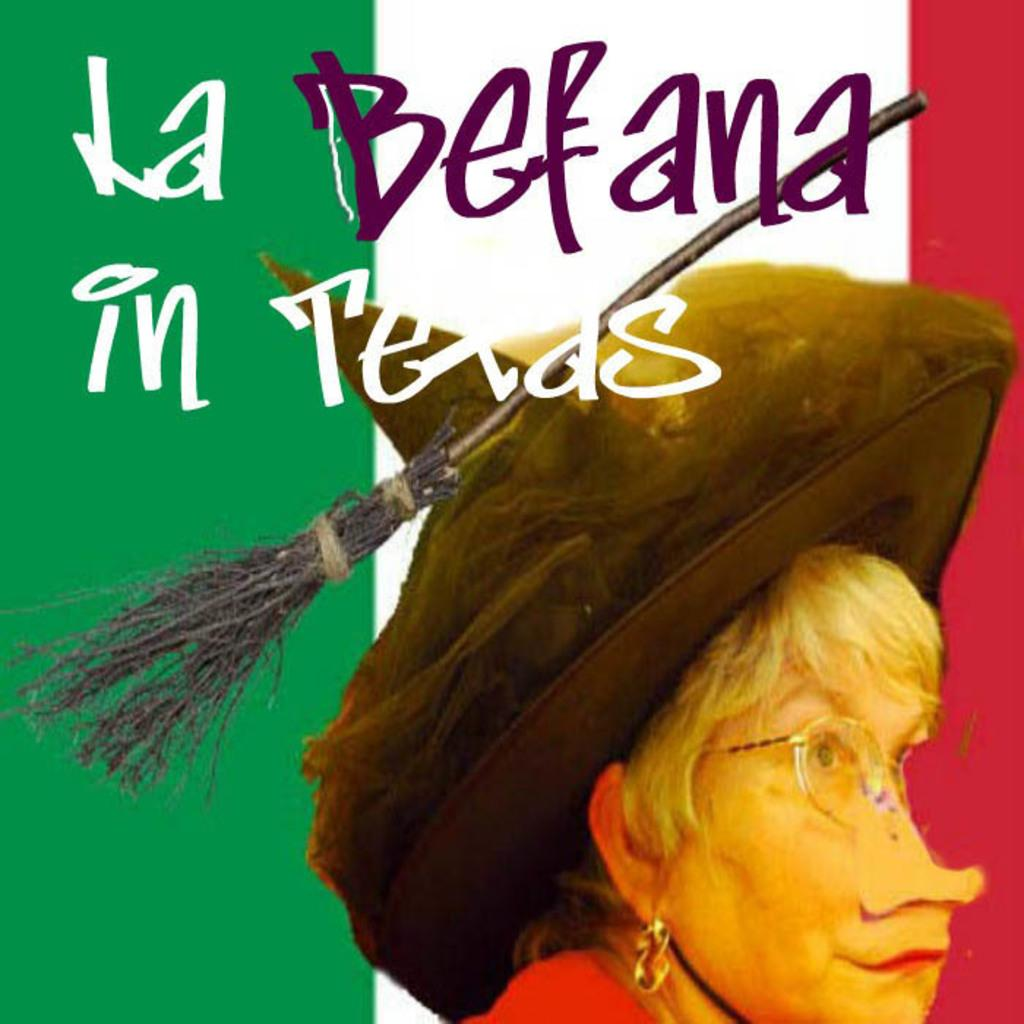Who is the main subject of the poster? The main subject of the poster is a lady. What accessories is the lady wearing in the poster? The lady is wearing specs and a hat in the poster. What is unique about the hat the lady is wearing? The hat has a broomstick on it. Is there any text present on the poster? Yes, there is text written on the image. What type of creature is starting a race in the image? There is no creature starting a race in the image; it features a lady wearing a hat with a broomstick on it. 